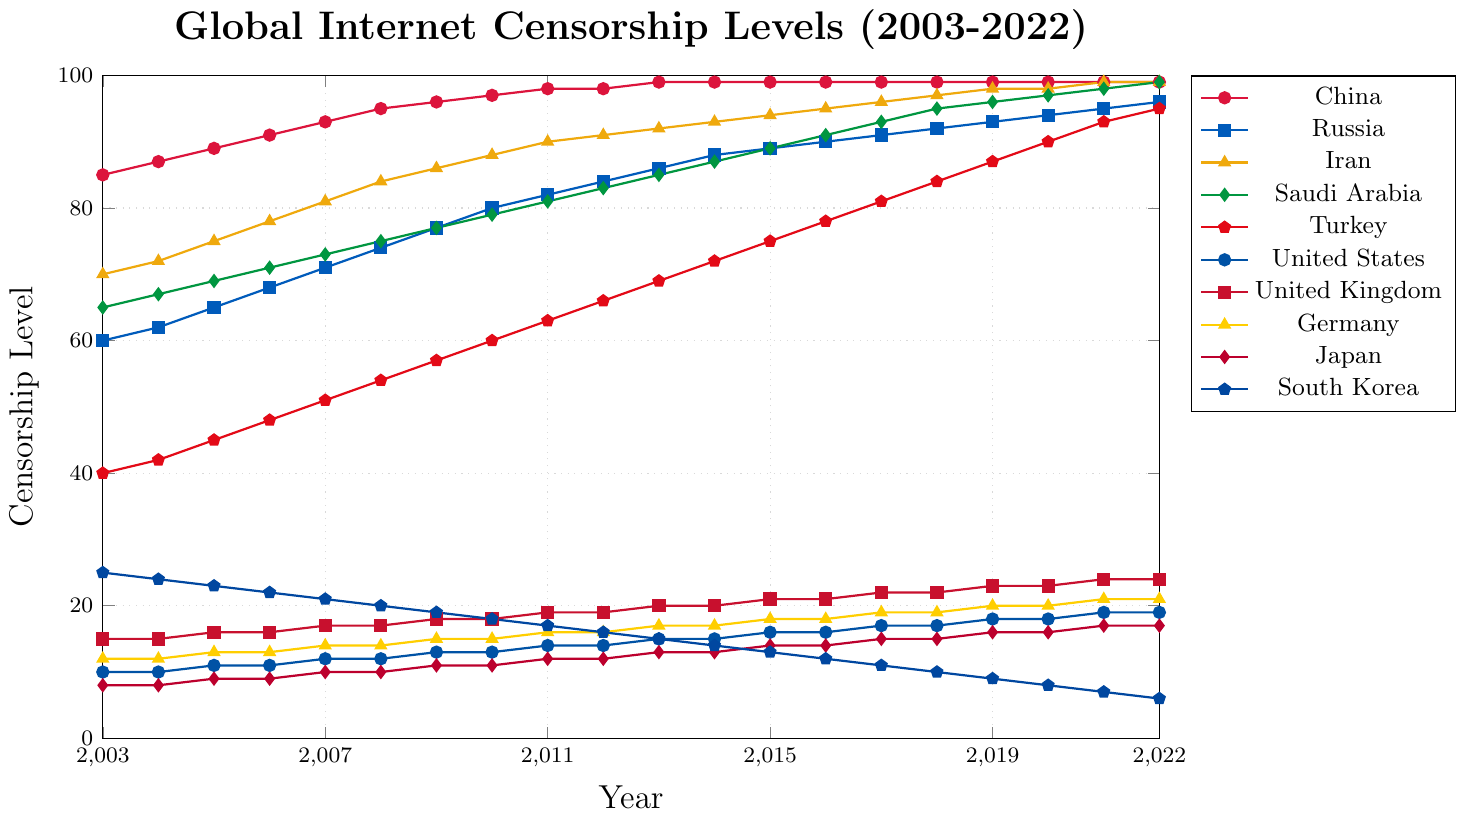Which country has the highest censorship level in 2022? To determine this, we need to compare the censorship levels of all countries in 2022. China, Iran, and Saudi Arabia are all at 99, other countries have lower values.
Answer: China, Iran, Saudi Arabia How did the censorship level in the United States change from 2003 to 2022? Look at the points for the United States on the chart. In 2003, the value was 10, and in 2022, it was 19. The difference is 19 - 10.
Answer: Increased by 9 Which country had the steepest increase in censorship levels over the 20 years? To find this, check the slope of the lines. The steepest increase is seen in Saudi Arabia, which goes from 65 in 2003 to 99 in 2022.
Answer: Saudi Arabia What is the average censorship level across all countries in 2010? Sum the censorship levels of all countries for 2010 and then divide by the number of countries (10). (97+80+88+79+60+13+18+15+11+18) / 10 = 47.9
Answer: 47.9 Which two countries had the closest censorship levels in 2015? Compare the values in 2015 and identify the closest pairs. Turkey and United States have values of 75 and 16, respectively, which are not close. A closer pair is Germany and United Kingdom at 18 and 21. However, Iran and Saudi Arabia at 94 and 89 are the closest.
Answer: Iran and Saudi Arabia How did the censorship level change in South Korea from 2003 to 2022? Observing the line for South Korea, it starts at 25 in 2003 and declines to 6 in 2022. The change is 25 - 6.
Answer: Decreased by 19 Which country has shown the most consistent censorship levels over the years? China has a line that rises quickly to 99 and then flattens, indicating consistent high levels.
Answer: China What was the combined censorship level in 2019 for Russia and Iran? Add the values for Russia and Iran in 2019: 93 (Russia) + 98 (Iran).
Answer: 191 Is there any country where censorship levels decreased over the time period? Review each line. South Korea is the only one with a decreasing trend, from 25 in 2003 to 6 in 2022.
Answer: South Korea 